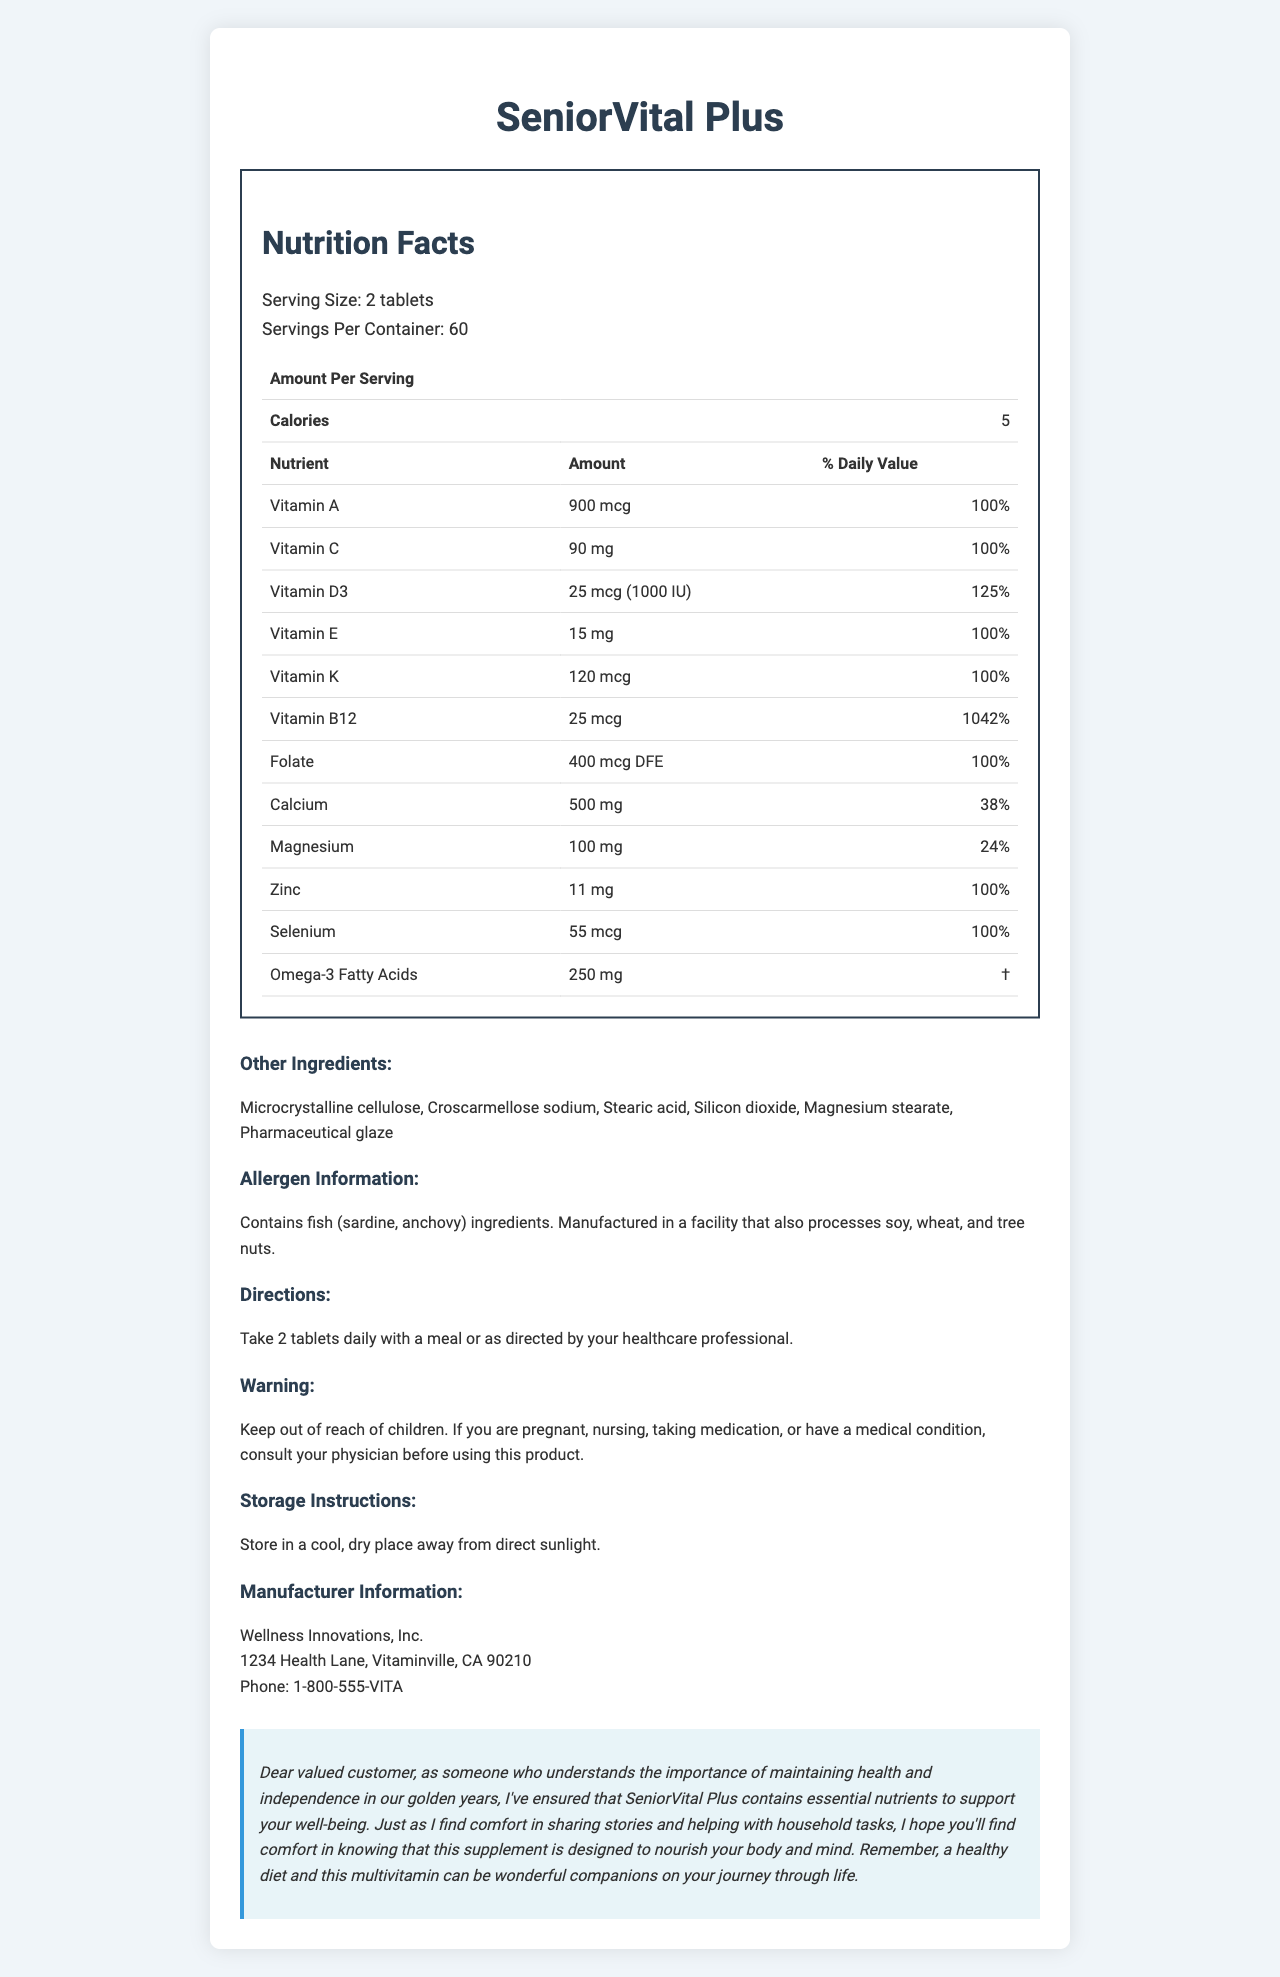what is the serving size for SeniorVital Plus? The serving size is clearly stated in the document as "2 tablets."
Answer: 2 tablets how many servings per container are there? The document mentions that there are 60 servings per container.
Answer: 60 how many calories are there per serving? According to the document, there are 5 calories per serving.
Answer: 5 which nutrient has the highest daily value percentage? The daily value percentage for Vitamin B12 is 1042%, which is the highest among the listed nutrients.
Answer: Vitamin B12 how much Vitamin D3 is in each serving? The document lists the amount of Vitamin D3 as 25 mcg (1000 IU) per serving.
Answer: 25 mcg (1000 IU) which of the following ingredients are present in the SeniorVital Plus tablets? A. Gelatin B. Microcrystalline cellulose C. Corn starch D. Sorbitol Among the options given, Microcrystalline cellulose is listed under the "other ingredients" for SeniorVital Plus.
Answer: B what are you advised to do if you are pregnant before taking this supplement? A. Take an extra tablet B. Consult your physician C. Store in a refrigerator D. Reduce serving size The document advises consulting your physician if you are pregnant before using this product.
Answer: B does the product contain any allergens? The document details that the product contains fish (sardine, anchovy) ingredients and is manufactured in a facility that also processes soy, wheat, and tree nuts.
Answer: Yes are there storage instructions provided in the document? The document advises storing the supplement in a cool, dry place away from direct sunlight.
Answer: Yes is the manufacturer located in the USA? The manufacturer is located at "1234 Health Lane, Vitaminville, CA 90210," which is in the USA.
Answer: Yes summarize the main idea of the document. The document outlines various aspects of the SeniorVital Plus supplement, intended for senior individuals. It includes essential nutrients, ingredient details, safety instructions, and storage guidelines.
Answer: The document provides detailed nutrition facts and usage information for SeniorVital Plus, a senior-friendly multivitamin supplement. It includes nutrient amounts, daily values, ingredients, allergen information, directions, warnings, storage instructions, and manufacturer details. The document also has a personalized note emphasizing the supplement's benefits for older adults. what is the source of Omega-3 Fatty Acids in this product? The document states the amount of Omega-3 Fatty Acids but does not provide information about their source.
Answer: Not enough information 